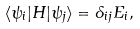<formula> <loc_0><loc_0><loc_500><loc_500>\langle \psi _ { i } | H | \psi _ { j } \rangle = \delta _ { i j } E _ { i } ,</formula> 